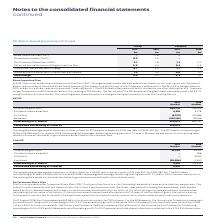According to Auto Trader's financial document, What was the weighted average market value per ordinary share for Irish SIP options exercised in 2019? According to the financial document, 350.0p. The relevant text states: "share for Irish SIP options exercised in 2019 was 350.0p (2018: 387.5p). The SIP shares outstanding at 31 March 2018 have fully vested (2018: had a weighted..." Also, What do the Options exercised prior to the vesting date relate to? those attributable to good leavers as defined by the scheme rules.. The document states: "hares released prior to the vesting date relate to those attributable to good leavers as defined by the scheme rules...." Also, For which years was the amount Outstanding at 31 March calculated? The document shows two values: 2019 and 2018. From the document: "2019 £m 2018 £m 2019 £m 2018 £m 2019 £m 2018 £m 2019 £m 2018 £m..." Additionally, In which year was the amount Outstanding at 1 April larger? According to the financial document, 2018. The relevant text states: "2019 £m 2018 £m 2019 £m 2018 £m..." Also, can you calculate: What was the change in the amount Outstanding at 1 April in 2019 from 2018? Based on the calculation: 35,922-44,431, the result is -8509. This is based on the information: "Outstanding at 1 April 35,922 44,431 Outstanding at 1 April 35,922 44,431..." The key data points involved are: 35,922, 44,431. Also, can you calculate: What was the percentage change in the amount Outstanding at 1 April in 2019 from 2018? To answer this question, I need to perform calculations using the financial data. The calculation is: (35,922-44,431)/44,431, which equals -19.15 (percentage). This is based on the information: "Outstanding at 1 April 35,922 44,431 Outstanding at 1 April 35,922 44,431..." The key data points involved are: 35,922, 44,431. 